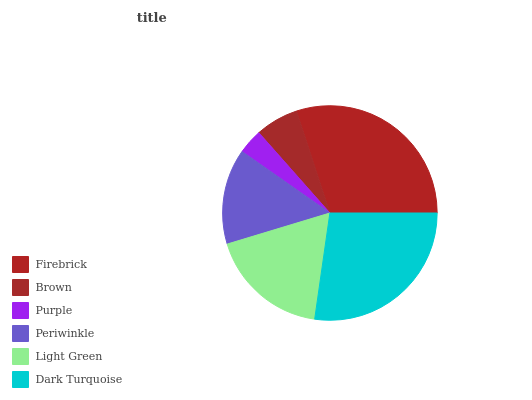Is Purple the minimum?
Answer yes or no. Yes. Is Firebrick the maximum?
Answer yes or no. Yes. Is Brown the minimum?
Answer yes or no. No. Is Brown the maximum?
Answer yes or no. No. Is Firebrick greater than Brown?
Answer yes or no. Yes. Is Brown less than Firebrick?
Answer yes or no. Yes. Is Brown greater than Firebrick?
Answer yes or no. No. Is Firebrick less than Brown?
Answer yes or no. No. Is Light Green the high median?
Answer yes or no. Yes. Is Periwinkle the low median?
Answer yes or no. Yes. Is Dark Turquoise the high median?
Answer yes or no. No. Is Dark Turquoise the low median?
Answer yes or no. No. 